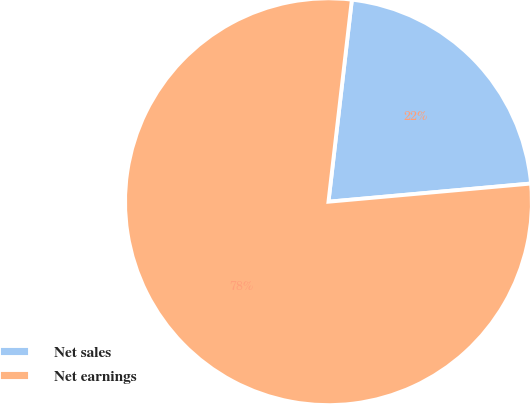<chart> <loc_0><loc_0><loc_500><loc_500><pie_chart><fcel>Net sales<fcel>Net earnings<nl><fcel>21.74%<fcel>78.26%<nl></chart> 